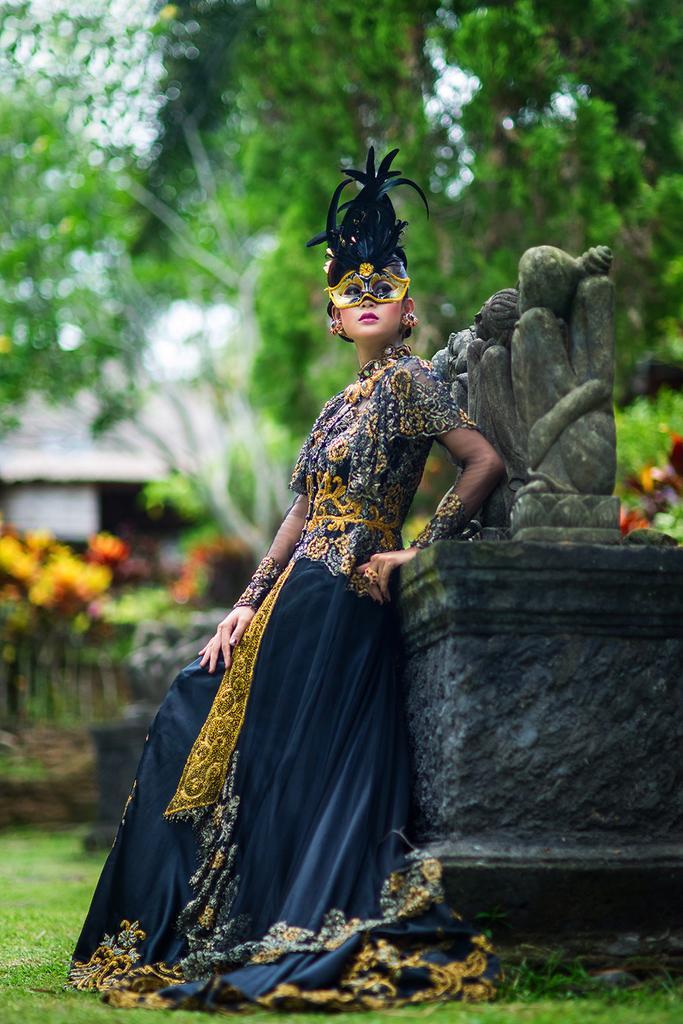In one or two sentences, can you explain what this image depicts? In this image I can see a person is wearing blue,yellow dress. I can see a person is wearing a mask,statue and few trees. 